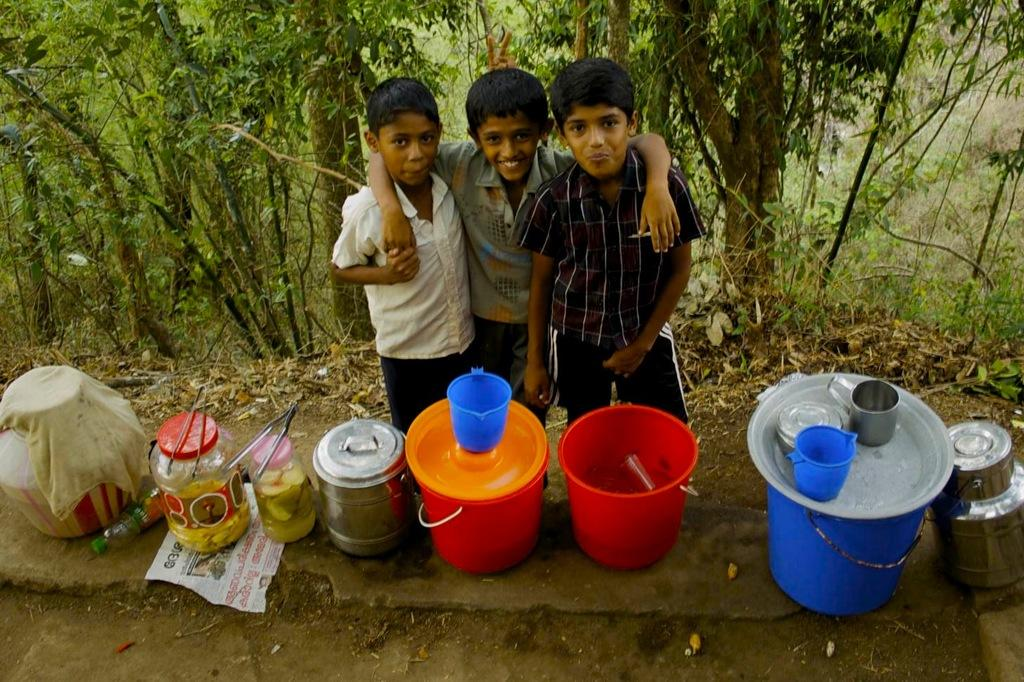How many children are in the image? There are three children in the image. What are the children doing in the image? The children are posing for a camera and smiling. What types of containers are visible in the image? There are bottles, jugs, and buckets in the image. What can be seen in the background of the image? There are trees in the background of the image. How many planes can be seen flying in the image? There are no planes visible in the image. What type of thread is being used by the children to create a pattern in the image? There is no thread present in the image; the children are simply posing for a camera. 